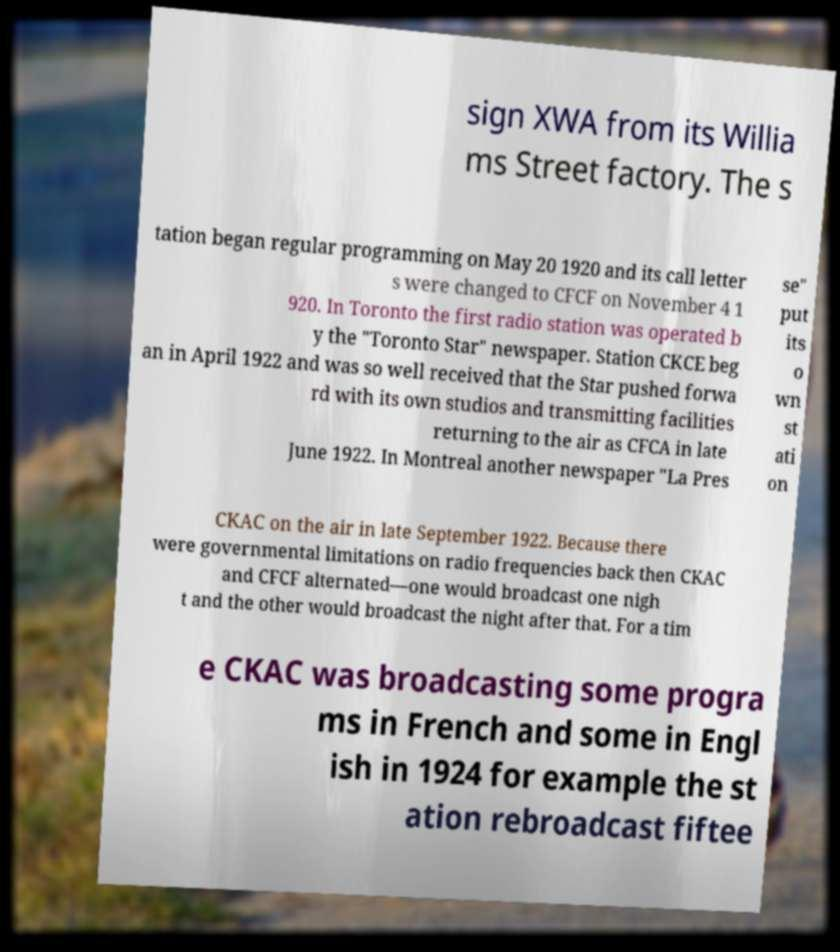There's text embedded in this image that I need extracted. Can you transcribe it verbatim? sign XWA from its Willia ms Street factory. The s tation began regular programming on May 20 1920 and its call letter s were changed to CFCF on November 4 1 920. In Toronto the first radio station was operated b y the "Toronto Star" newspaper. Station CKCE beg an in April 1922 and was so well received that the Star pushed forwa rd with its own studios and transmitting facilities returning to the air as CFCA in late June 1922. In Montreal another newspaper "La Pres se" put its o wn st ati on CKAC on the air in late September 1922. Because there were governmental limitations on radio frequencies back then CKAC and CFCF alternated—one would broadcast one nigh t and the other would broadcast the night after that. For a tim e CKAC was broadcasting some progra ms in French and some in Engl ish in 1924 for example the st ation rebroadcast fiftee 